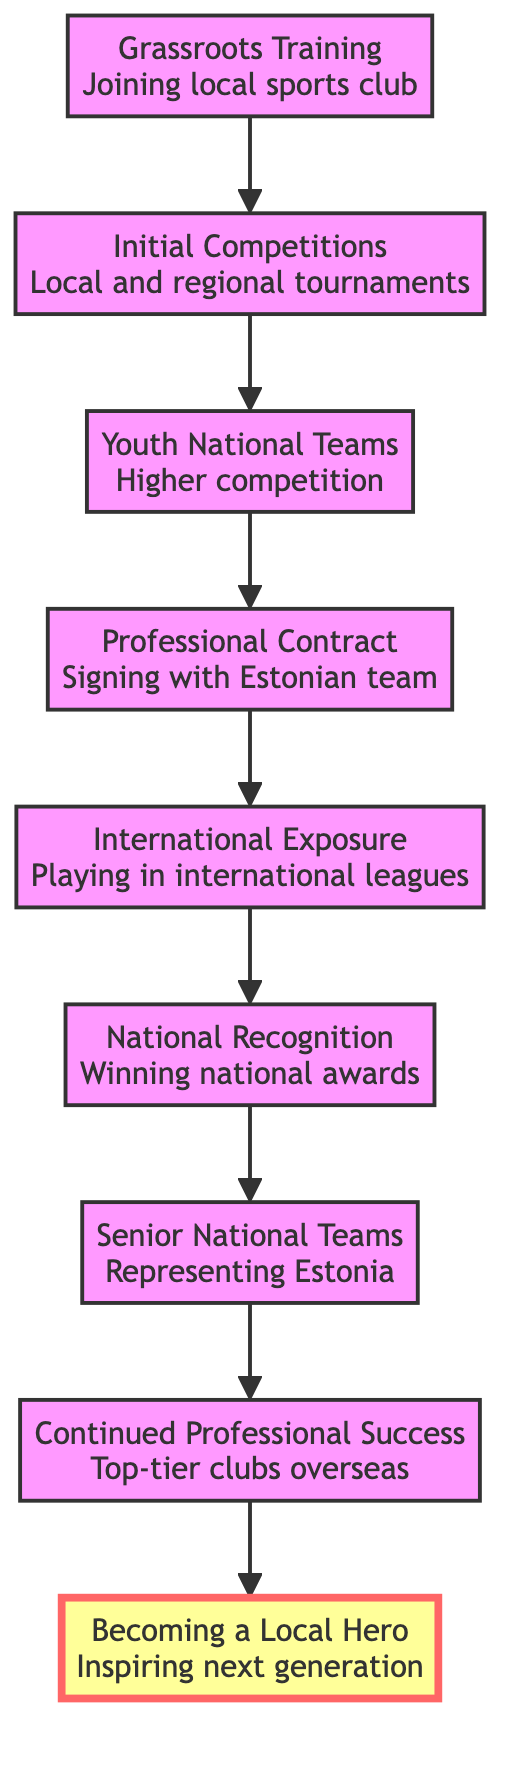What is the first step in the career path? The first step listed in the diagram is "Grassroots Training", which is the starting point for the athlete's journey.
Answer: Grassroots Training How many total elements are in the flowchart? By counting the elements from "Grassroots Training" to "Becoming a Local Hero", there are 9 distinct elements.
Answer: 9 What is the last stage of the athlete’s career path? The last stage in the flowchart is "Becoming a Local Hero", which represents the culmination of the athlete's achievements and contributions.
Answer: Becoming a Local Hero What signifies the transition from local competitions to higher levels? The transition from "Initial Competitions" to "Youth National Teams" signifies moving to a higher competitive level.
Answer: Youth National Teams What achievement follows "National Recognition"? After "National Recognition", the next step in the career path is "Senior National Teams", indicating the athlete is called up for the national senior team.
Answer: Senior National Teams Which element represents signing a contract with a professional team? The element "Professional Contract" in the diagram represents the stage where an athlete signs a deal with a professional team.
Answer: Professional Contract What is the icon used for "International Exposure"? The icon associated with "International Exposure" in the flowchart is a globe emoji, signifying global opportunities.
Answer: 🌍 How does an athlete advance from youth to senior level? An athlete advances from youth level to senior level by moving from "Youth National Teams" to "Senior National Teams", marking the transition to representing the country at a senior level.
Answer: Senior National Teams What does "Continued Professional Success" involve? "Continued Professional Success" involves securing roles in top-tier clubs or teams outside of Estonia, indicating progress in an athlete's career.
Answer: Top-tier clubs overseas 